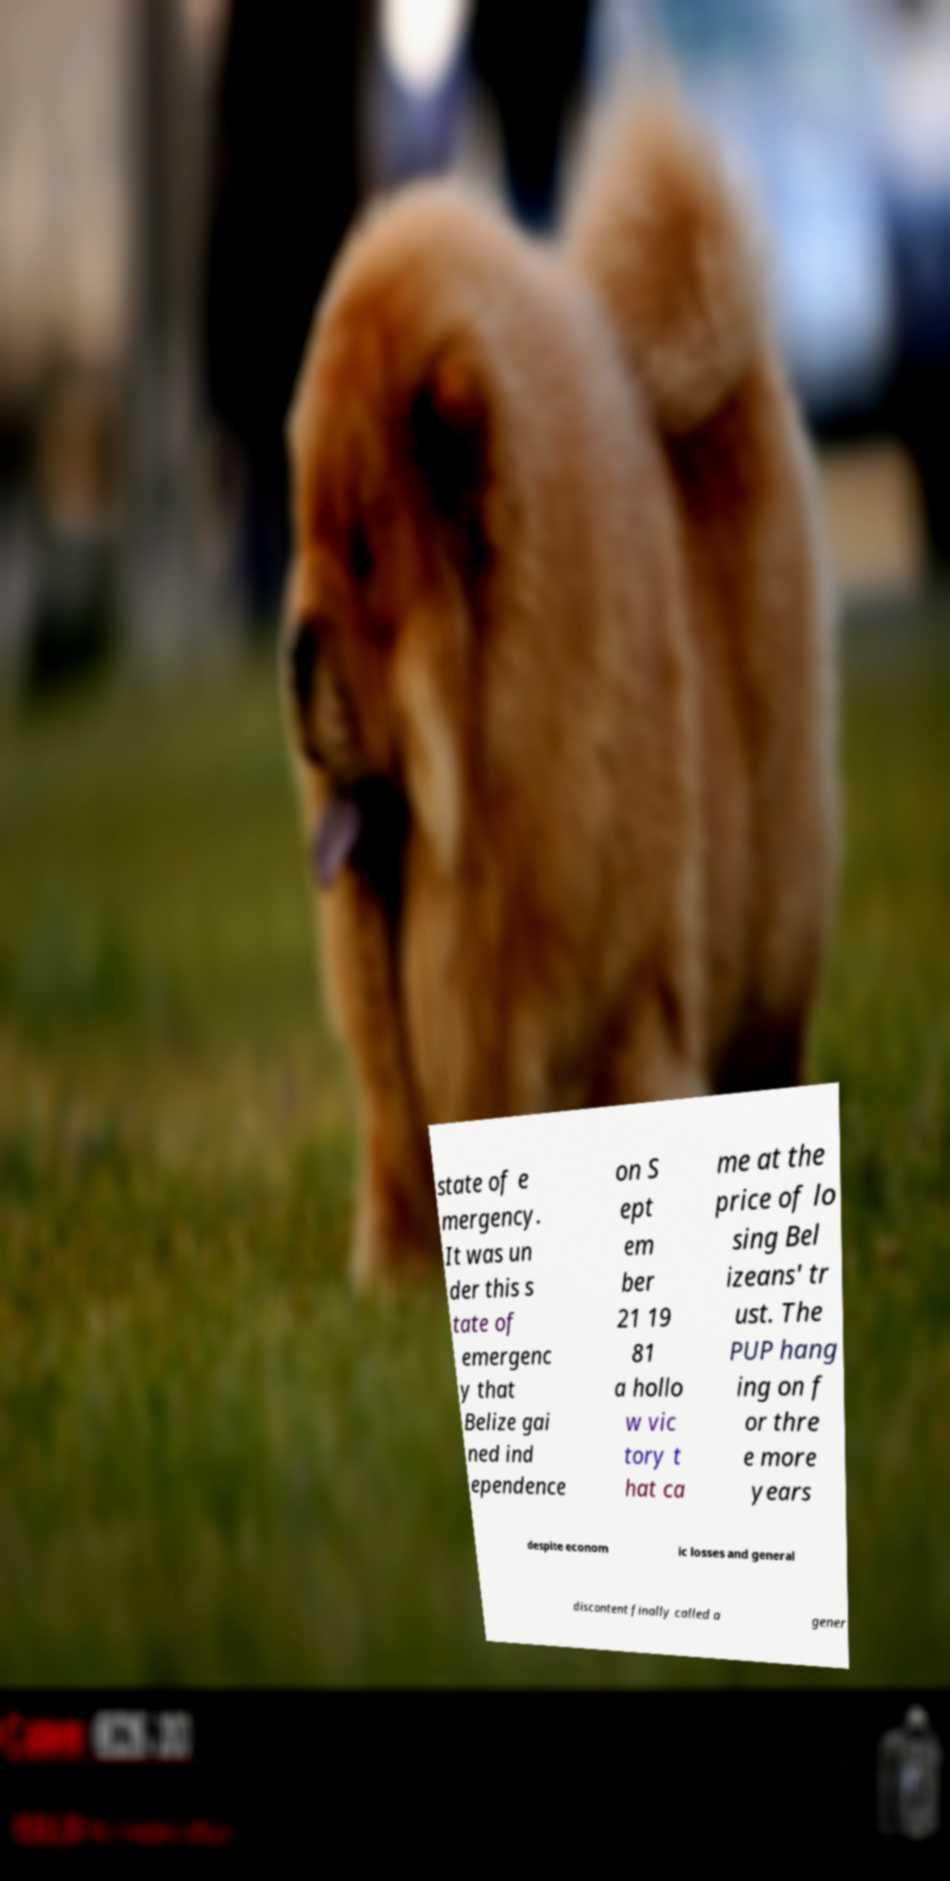Please read and relay the text visible in this image. What does it say? state of e mergency. It was un der this s tate of emergenc y that Belize gai ned ind ependence on S ept em ber 21 19 81 a hollo w vic tory t hat ca me at the price of lo sing Bel izeans' tr ust. The PUP hang ing on f or thre e more years despite econom ic losses and general discontent finally called a gener 